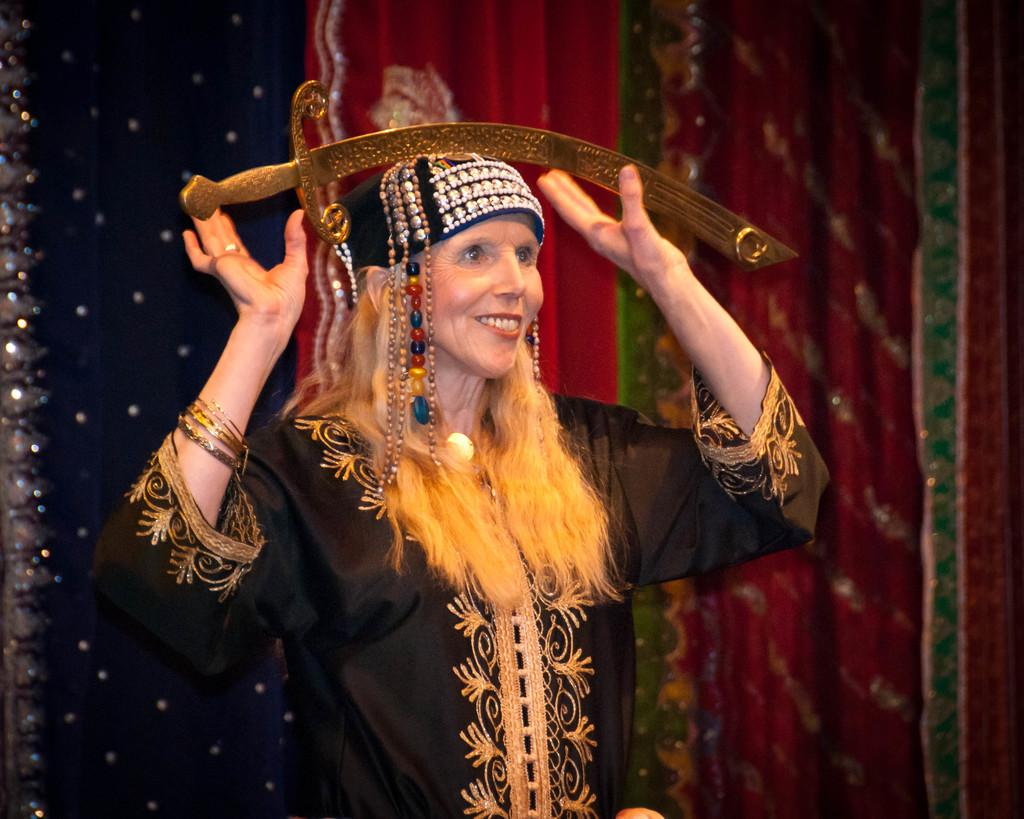Who is present in the image? There is a woman in the image. What is the woman wearing? The woman is wearing a black dress. What expression does the woman have? The woman is smiling. What can be seen in the background of the image? There is a red curtain in the background of the image. What type of truck can be seen parked outside the library in the image? There is no truck or library present in the image; it features a woman wearing a black dress and smiling, with a red curtain in the background. 